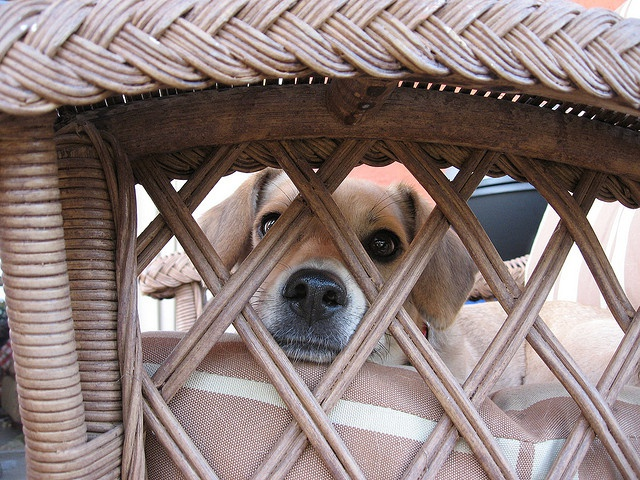Describe the objects in this image and their specific colors. I can see chair in darkgray, lightgray, black, maroon, and gray tones and dog in lavender, darkgray, gray, and lightgray tones in this image. 